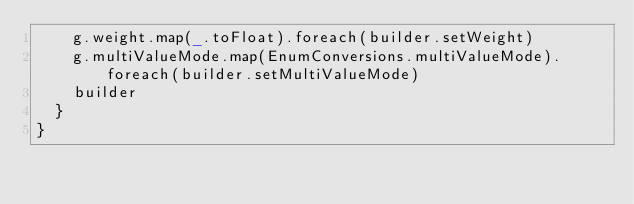<code> <loc_0><loc_0><loc_500><loc_500><_Scala_>    g.weight.map(_.toFloat).foreach(builder.setWeight)
    g.multiValueMode.map(EnumConversions.multiValueMode).foreach(builder.setMultiValueMode)
    builder
  }
}
</code> 